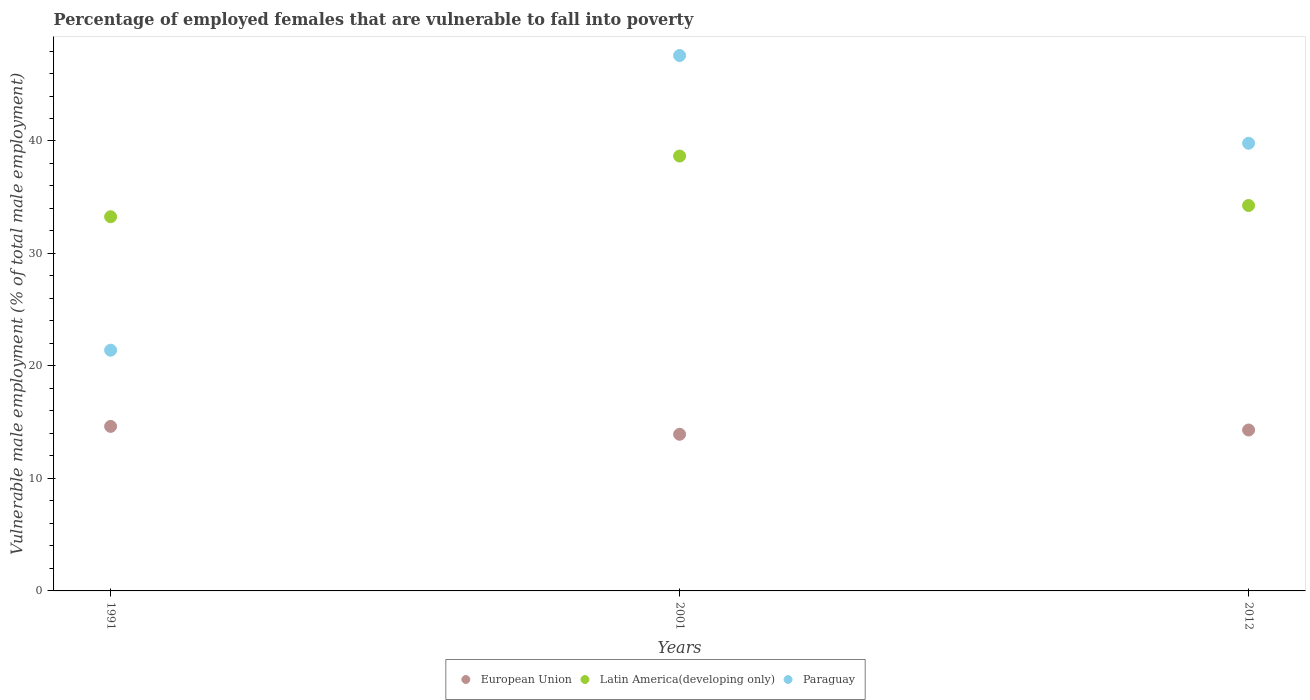How many different coloured dotlines are there?
Your answer should be compact. 3. Is the number of dotlines equal to the number of legend labels?
Make the answer very short. Yes. What is the percentage of employed females who are vulnerable to fall into poverty in Latin America(developing only) in 1991?
Your response must be concise. 33.27. Across all years, what is the maximum percentage of employed females who are vulnerable to fall into poverty in Latin America(developing only)?
Keep it short and to the point. 38.66. Across all years, what is the minimum percentage of employed females who are vulnerable to fall into poverty in European Union?
Offer a terse response. 13.93. In which year was the percentage of employed females who are vulnerable to fall into poverty in Paraguay maximum?
Your response must be concise. 2001. In which year was the percentage of employed females who are vulnerable to fall into poverty in European Union minimum?
Keep it short and to the point. 2001. What is the total percentage of employed females who are vulnerable to fall into poverty in Latin America(developing only) in the graph?
Keep it short and to the point. 106.19. What is the difference between the percentage of employed females who are vulnerable to fall into poverty in Paraguay in 1991 and that in 2012?
Offer a very short reply. -18.4. What is the difference between the percentage of employed females who are vulnerable to fall into poverty in European Union in 2001 and the percentage of employed females who are vulnerable to fall into poverty in Latin America(developing only) in 2012?
Your answer should be compact. -20.34. What is the average percentage of employed females who are vulnerable to fall into poverty in Latin America(developing only) per year?
Your response must be concise. 35.4. In the year 2001, what is the difference between the percentage of employed females who are vulnerable to fall into poverty in European Union and percentage of employed females who are vulnerable to fall into poverty in Latin America(developing only)?
Your answer should be very brief. -24.74. In how many years, is the percentage of employed females who are vulnerable to fall into poverty in Paraguay greater than 44 %?
Your answer should be compact. 1. What is the ratio of the percentage of employed females who are vulnerable to fall into poverty in Latin America(developing only) in 1991 to that in 2012?
Make the answer very short. 0.97. Is the percentage of employed females who are vulnerable to fall into poverty in Paraguay in 2001 less than that in 2012?
Give a very brief answer. No. What is the difference between the highest and the second highest percentage of employed females who are vulnerable to fall into poverty in Paraguay?
Your response must be concise. 7.8. What is the difference between the highest and the lowest percentage of employed females who are vulnerable to fall into poverty in Paraguay?
Make the answer very short. 26.2. Is the sum of the percentage of employed females who are vulnerable to fall into poverty in Paraguay in 1991 and 2012 greater than the maximum percentage of employed females who are vulnerable to fall into poverty in Latin America(developing only) across all years?
Your answer should be compact. Yes. Does the percentage of employed females who are vulnerable to fall into poverty in Paraguay monotonically increase over the years?
Your answer should be compact. No. How many dotlines are there?
Your answer should be compact. 3. How many years are there in the graph?
Keep it short and to the point. 3. Are the values on the major ticks of Y-axis written in scientific E-notation?
Your answer should be compact. No. Does the graph contain any zero values?
Keep it short and to the point. No. How many legend labels are there?
Ensure brevity in your answer.  3. How are the legend labels stacked?
Ensure brevity in your answer.  Horizontal. What is the title of the graph?
Your answer should be very brief. Percentage of employed females that are vulnerable to fall into poverty. What is the label or title of the X-axis?
Ensure brevity in your answer.  Years. What is the label or title of the Y-axis?
Provide a succinct answer. Vulnerable male employment (% of total male employment). What is the Vulnerable male employment (% of total male employment) in European Union in 1991?
Keep it short and to the point. 14.63. What is the Vulnerable male employment (% of total male employment) of Latin America(developing only) in 1991?
Your response must be concise. 33.27. What is the Vulnerable male employment (% of total male employment) of Paraguay in 1991?
Give a very brief answer. 21.4. What is the Vulnerable male employment (% of total male employment) of European Union in 2001?
Your response must be concise. 13.93. What is the Vulnerable male employment (% of total male employment) in Latin America(developing only) in 2001?
Give a very brief answer. 38.66. What is the Vulnerable male employment (% of total male employment) of Paraguay in 2001?
Provide a succinct answer. 47.6. What is the Vulnerable male employment (% of total male employment) in European Union in 2012?
Offer a very short reply. 14.31. What is the Vulnerable male employment (% of total male employment) of Latin America(developing only) in 2012?
Keep it short and to the point. 34.27. What is the Vulnerable male employment (% of total male employment) of Paraguay in 2012?
Ensure brevity in your answer.  39.8. Across all years, what is the maximum Vulnerable male employment (% of total male employment) in European Union?
Your response must be concise. 14.63. Across all years, what is the maximum Vulnerable male employment (% of total male employment) of Latin America(developing only)?
Keep it short and to the point. 38.66. Across all years, what is the maximum Vulnerable male employment (% of total male employment) of Paraguay?
Provide a short and direct response. 47.6. Across all years, what is the minimum Vulnerable male employment (% of total male employment) of European Union?
Ensure brevity in your answer.  13.93. Across all years, what is the minimum Vulnerable male employment (% of total male employment) in Latin America(developing only)?
Make the answer very short. 33.27. Across all years, what is the minimum Vulnerable male employment (% of total male employment) in Paraguay?
Provide a succinct answer. 21.4. What is the total Vulnerable male employment (% of total male employment) of European Union in the graph?
Give a very brief answer. 42.86. What is the total Vulnerable male employment (% of total male employment) of Latin America(developing only) in the graph?
Your answer should be compact. 106.19. What is the total Vulnerable male employment (% of total male employment) in Paraguay in the graph?
Your answer should be compact. 108.8. What is the difference between the Vulnerable male employment (% of total male employment) in European Union in 1991 and that in 2001?
Offer a terse response. 0.7. What is the difference between the Vulnerable male employment (% of total male employment) of Latin America(developing only) in 1991 and that in 2001?
Keep it short and to the point. -5.4. What is the difference between the Vulnerable male employment (% of total male employment) in Paraguay in 1991 and that in 2001?
Your response must be concise. -26.2. What is the difference between the Vulnerable male employment (% of total male employment) in European Union in 1991 and that in 2012?
Ensure brevity in your answer.  0.32. What is the difference between the Vulnerable male employment (% of total male employment) in Latin America(developing only) in 1991 and that in 2012?
Ensure brevity in your answer.  -1. What is the difference between the Vulnerable male employment (% of total male employment) of Paraguay in 1991 and that in 2012?
Provide a succinct answer. -18.4. What is the difference between the Vulnerable male employment (% of total male employment) in European Union in 2001 and that in 2012?
Ensure brevity in your answer.  -0.38. What is the difference between the Vulnerable male employment (% of total male employment) of Latin America(developing only) in 2001 and that in 2012?
Make the answer very short. 4.4. What is the difference between the Vulnerable male employment (% of total male employment) of Paraguay in 2001 and that in 2012?
Offer a terse response. 7.8. What is the difference between the Vulnerable male employment (% of total male employment) in European Union in 1991 and the Vulnerable male employment (% of total male employment) in Latin America(developing only) in 2001?
Your answer should be compact. -24.04. What is the difference between the Vulnerable male employment (% of total male employment) in European Union in 1991 and the Vulnerable male employment (% of total male employment) in Paraguay in 2001?
Ensure brevity in your answer.  -32.97. What is the difference between the Vulnerable male employment (% of total male employment) of Latin America(developing only) in 1991 and the Vulnerable male employment (% of total male employment) of Paraguay in 2001?
Your answer should be compact. -14.33. What is the difference between the Vulnerable male employment (% of total male employment) of European Union in 1991 and the Vulnerable male employment (% of total male employment) of Latin America(developing only) in 2012?
Ensure brevity in your answer.  -19.64. What is the difference between the Vulnerable male employment (% of total male employment) of European Union in 1991 and the Vulnerable male employment (% of total male employment) of Paraguay in 2012?
Provide a short and direct response. -25.17. What is the difference between the Vulnerable male employment (% of total male employment) of Latin America(developing only) in 1991 and the Vulnerable male employment (% of total male employment) of Paraguay in 2012?
Offer a very short reply. -6.53. What is the difference between the Vulnerable male employment (% of total male employment) in European Union in 2001 and the Vulnerable male employment (% of total male employment) in Latin America(developing only) in 2012?
Offer a terse response. -20.34. What is the difference between the Vulnerable male employment (% of total male employment) of European Union in 2001 and the Vulnerable male employment (% of total male employment) of Paraguay in 2012?
Your answer should be compact. -25.87. What is the difference between the Vulnerable male employment (% of total male employment) in Latin America(developing only) in 2001 and the Vulnerable male employment (% of total male employment) in Paraguay in 2012?
Keep it short and to the point. -1.14. What is the average Vulnerable male employment (% of total male employment) in European Union per year?
Your answer should be very brief. 14.29. What is the average Vulnerable male employment (% of total male employment) of Latin America(developing only) per year?
Your response must be concise. 35.4. What is the average Vulnerable male employment (% of total male employment) in Paraguay per year?
Provide a short and direct response. 36.27. In the year 1991, what is the difference between the Vulnerable male employment (% of total male employment) in European Union and Vulnerable male employment (% of total male employment) in Latin America(developing only)?
Your answer should be compact. -18.64. In the year 1991, what is the difference between the Vulnerable male employment (% of total male employment) in European Union and Vulnerable male employment (% of total male employment) in Paraguay?
Offer a very short reply. -6.77. In the year 1991, what is the difference between the Vulnerable male employment (% of total male employment) in Latin America(developing only) and Vulnerable male employment (% of total male employment) in Paraguay?
Provide a succinct answer. 11.87. In the year 2001, what is the difference between the Vulnerable male employment (% of total male employment) of European Union and Vulnerable male employment (% of total male employment) of Latin America(developing only)?
Ensure brevity in your answer.  -24.74. In the year 2001, what is the difference between the Vulnerable male employment (% of total male employment) of European Union and Vulnerable male employment (% of total male employment) of Paraguay?
Your response must be concise. -33.67. In the year 2001, what is the difference between the Vulnerable male employment (% of total male employment) in Latin America(developing only) and Vulnerable male employment (% of total male employment) in Paraguay?
Your answer should be compact. -8.94. In the year 2012, what is the difference between the Vulnerable male employment (% of total male employment) of European Union and Vulnerable male employment (% of total male employment) of Latin America(developing only)?
Ensure brevity in your answer.  -19.96. In the year 2012, what is the difference between the Vulnerable male employment (% of total male employment) in European Union and Vulnerable male employment (% of total male employment) in Paraguay?
Offer a terse response. -25.49. In the year 2012, what is the difference between the Vulnerable male employment (% of total male employment) in Latin America(developing only) and Vulnerable male employment (% of total male employment) in Paraguay?
Offer a very short reply. -5.53. What is the ratio of the Vulnerable male employment (% of total male employment) of European Union in 1991 to that in 2001?
Your answer should be very brief. 1.05. What is the ratio of the Vulnerable male employment (% of total male employment) of Latin America(developing only) in 1991 to that in 2001?
Offer a very short reply. 0.86. What is the ratio of the Vulnerable male employment (% of total male employment) in Paraguay in 1991 to that in 2001?
Keep it short and to the point. 0.45. What is the ratio of the Vulnerable male employment (% of total male employment) in European Union in 1991 to that in 2012?
Make the answer very short. 1.02. What is the ratio of the Vulnerable male employment (% of total male employment) of Latin America(developing only) in 1991 to that in 2012?
Offer a terse response. 0.97. What is the ratio of the Vulnerable male employment (% of total male employment) of Paraguay in 1991 to that in 2012?
Offer a terse response. 0.54. What is the ratio of the Vulnerable male employment (% of total male employment) in European Union in 2001 to that in 2012?
Make the answer very short. 0.97. What is the ratio of the Vulnerable male employment (% of total male employment) of Latin America(developing only) in 2001 to that in 2012?
Provide a succinct answer. 1.13. What is the ratio of the Vulnerable male employment (% of total male employment) of Paraguay in 2001 to that in 2012?
Your response must be concise. 1.2. What is the difference between the highest and the second highest Vulnerable male employment (% of total male employment) of European Union?
Keep it short and to the point. 0.32. What is the difference between the highest and the second highest Vulnerable male employment (% of total male employment) in Latin America(developing only)?
Offer a terse response. 4.4. What is the difference between the highest and the second highest Vulnerable male employment (% of total male employment) of Paraguay?
Your response must be concise. 7.8. What is the difference between the highest and the lowest Vulnerable male employment (% of total male employment) of European Union?
Your response must be concise. 0.7. What is the difference between the highest and the lowest Vulnerable male employment (% of total male employment) of Latin America(developing only)?
Provide a short and direct response. 5.4. What is the difference between the highest and the lowest Vulnerable male employment (% of total male employment) in Paraguay?
Offer a terse response. 26.2. 